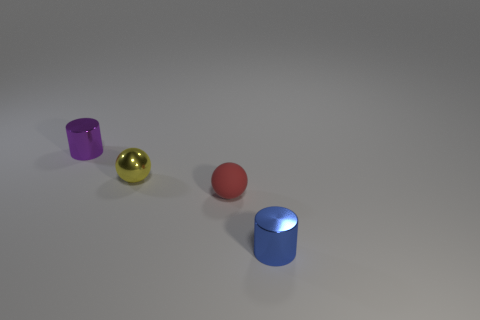The metallic ball that is the same size as the blue metal cylinder is what color?
Your answer should be very brief. Yellow. Is the number of small red rubber spheres that are on the left side of the tiny yellow metallic sphere the same as the number of purple shiny cylinders?
Give a very brief answer. No. There is a cylinder that is to the right of the shiny cylinder behind the blue cylinder; what is its color?
Offer a terse response. Blue. How big is the cylinder that is in front of the small shiny cylinder that is on the left side of the red thing?
Offer a terse response. Small. How many other objects are there of the same size as the purple metal cylinder?
Your answer should be compact. 3. What color is the small cylinder behind the small cylinder that is on the right side of the tiny metallic cylinder that is behind the small blue metal thing?
Your response must be concise. Purple. How many other objects are the same shape as the matte thing?
Provide a short and direct response. 1. What shape is the object that is on the right side of the tiny rubber object?
Your answer should be very brief. Cylinder. There is a cylinder that is in front of the purple object; is there a small yellow ball to the left of it?
Provide a short and direct response. Yes. What color is the small object that is to the right of the yellow shiny sphere and behind the blue shiny cylinder?
Ensure brevity in your answer.  Red. 